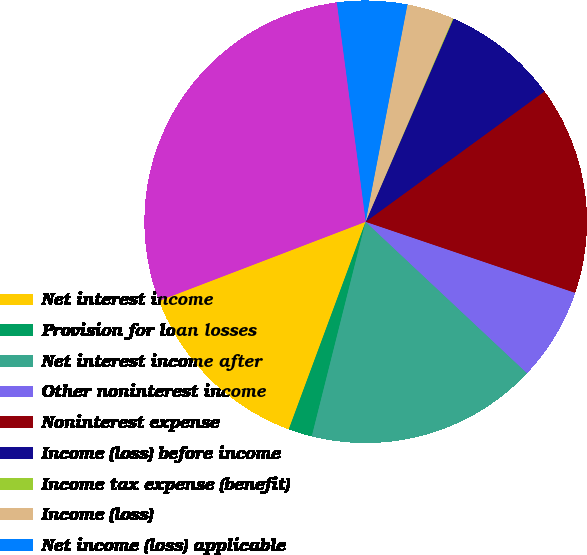<chart> <loc_0><loc_0><loc_500><loc_500><pie_chart><fcel>Net interest income<fcel>Provision for loan losses<fcel>Net interest income after<fcel>Other noninterest income<fcel>Noninterest expense<fcel>Income (loss) before income<fcel>Income tax expense (benefit)<fcel>Income (loss)<fcel>Net income (loss) applicable<fcel>Total assets<nl><fcel>13.54%<fcel>1.73%<fcel>16.92%<fcel>6.79%<fcel>15.23%<fcel>8.48%<fcel>0.05%<fcel>3.42%<fcel>5.11%<fcel>28.73%<nl></chart> 